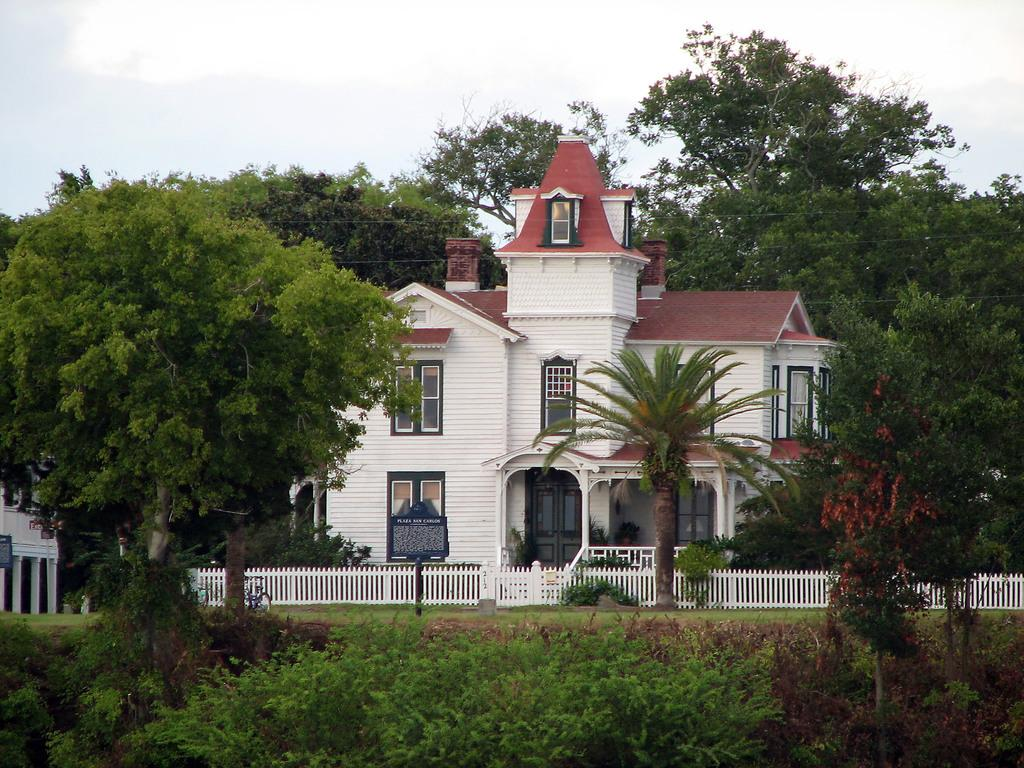What is the main subject of the image? There is a building at the center of the image. What can be seen on both sides of the building? Trees and plants are present on both the front and back sides of the building. What is visible in the background of the image? The sky is visible in the background of the image. How many boats are docked near the building in the image? There are no boats present in the image; it only features a building with trees and plants on both sides and the sky visible in the background. 